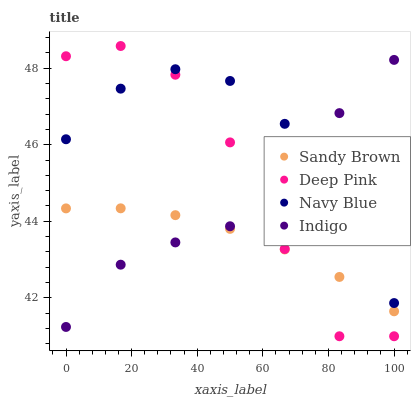Does Sandy Brown have the minimum area under the curve?
Answer yes or no. Yes. Does Navy Blue have the maximum area under the curve?
Answer yes or no. Yes. Does Deep Pink have the minimum area under the curve?
Answer yes or no. No. Does Deep Pink have the maximum area under the curve?
Answer yes or no. No. Is Sandy Brown the smoothest?
Answer yes or no. Yes. Is Deep Pink the roughest?
Answer yes or no. Yes. Is Deep Pink the smoothest?
Answer yes or no. No. Is Sandy Brown the roughest?
Answer yes or no. No. Does Deep Pink have the lowest value?
Answer yes or no. Yes. Does Sandy Brown have the lowest value?
Answer yes or no. No. Does Deep Pink have the highest value?
Answer yes or no. Yes. Does Sandy Brown have the highest value?
Answer yes or no. No. Is Sandy Brown less than Navy Blue?
Answer yes or no. Yes. Is Navy Blue greater than Sandy Brown?
Answer yes or no. Yes. Does Deep Pink intersect Indigo?
Answer yes or no. Yes. Is Deep Pink less than Indigo?
Answer yes or no. No. Is Deep Pink greater than Indigo?
Answer yes or no. No. Does Sandy Brown intersect Navy Blue?
Answer yes or no. No. 